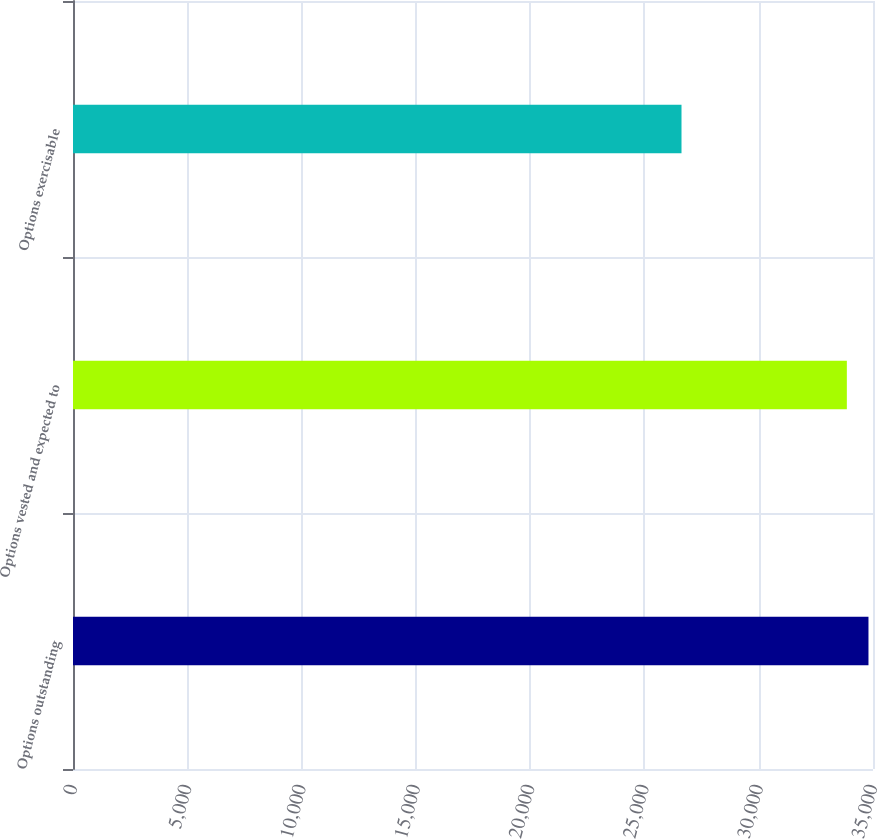<chart> <loc_0><loc_0><loc_500><loc_500><bar_chart><fcel>Options outstanding<fcel>Options vested and expected to<fcel>Options exercisable<nl><fcel>34802<fcel>33856<fcel>26622<nl></chart> 